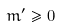<formula> <loc_0><loc_0><loc_500><loc_500>m ^ { \prime } \geq 0</formula> 